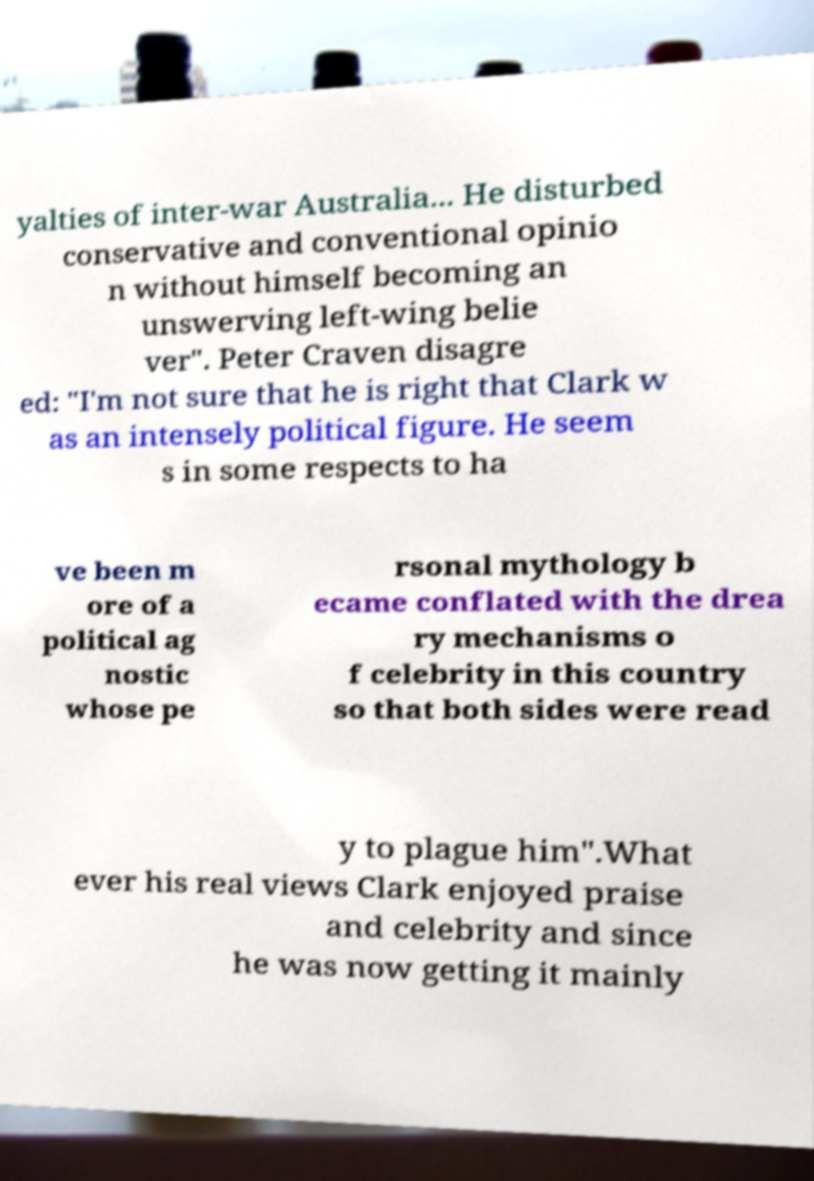Can you accurately transcribe the text from the provided image for me? yalties of inter-war Australia... He disturbed conservative and conventional opinio n without himself becoming an unswerving left-wing belie ver". Peter Craven disagre ed: "I'm not sure that he is right that Clark w as an intensely political figure. He seem s in some respects to ha ve been m ore of a political ag nostic whose pe rsonal mythology b ecame conflated with the drea ry mechanisms o f celebrity in this country so that both sides were read y to plague him".What ever his real views Clark enjoyed praise and celebrity and since he was now getting it mainly 